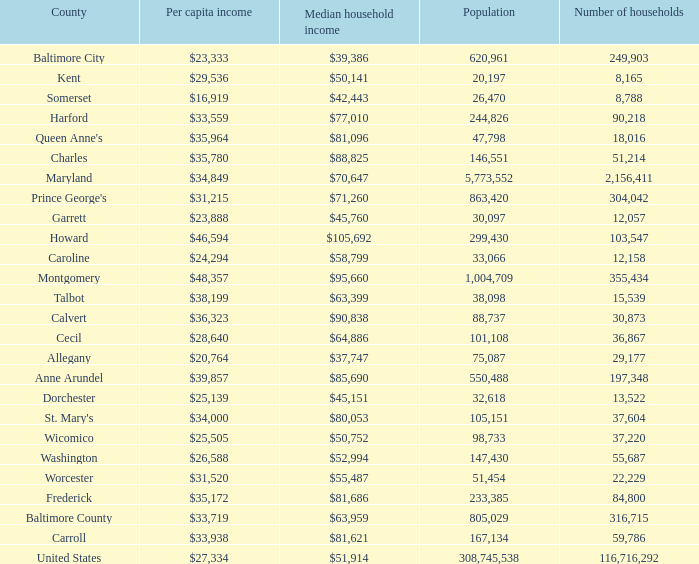What is the per capital income for Washington county? $26,588. 